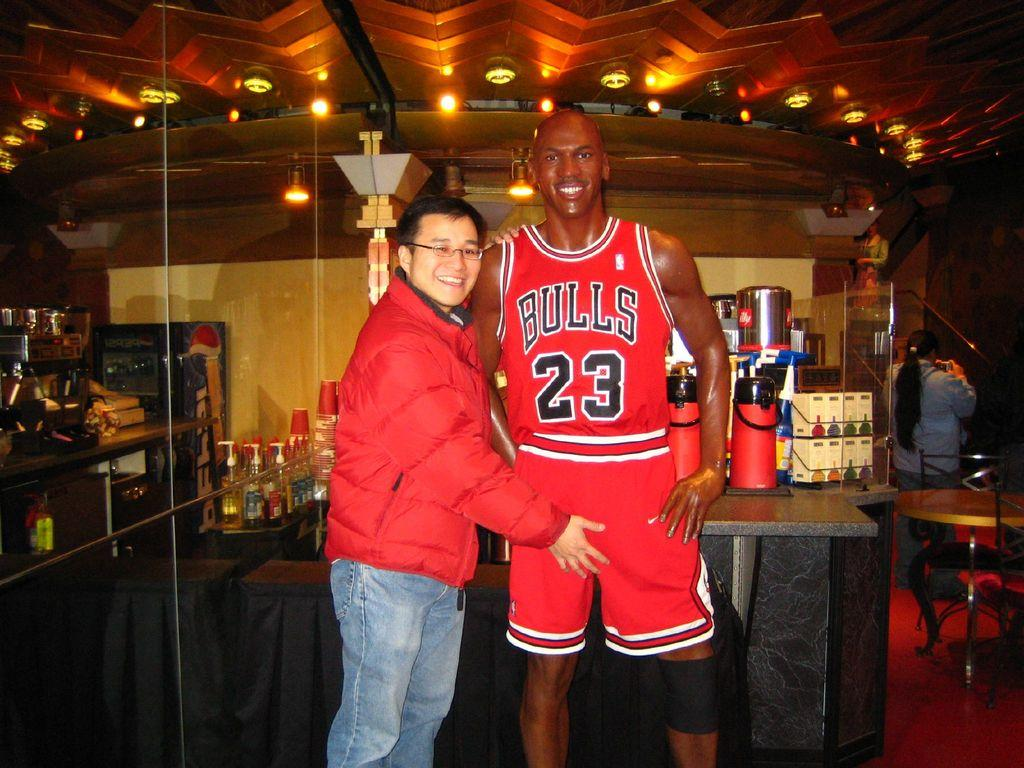<image>
Give a short and clear explanation of the subsequent image. A man makes a rude gesture to a figure of Michael Jordan in a Bulls jersey. 